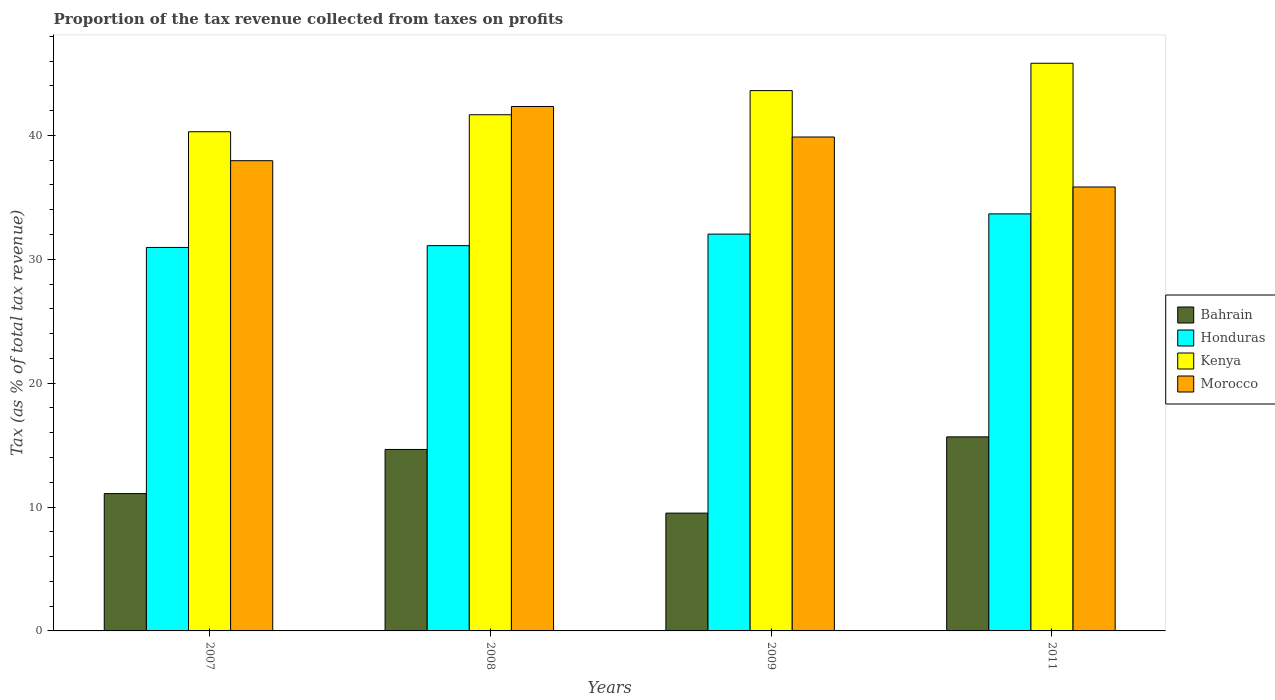How many different coloured bars are there?
Offer a very short reply. 4. How many groups of bars are there?
Ensure brevity in your answer.  4. Are the number of bars per tick equal to the number of legend labels?
Make the answer very short. Yes. Are the number of bars on each tick of the X-axis equal?
Provide a succinct answer. Yes. What is the label of the 3rd group of bars from the left?
Offer a terse response. 2009. In how many cases, is the number of bars for a given year not equal to the number of legend labels?
Make the answer very short. 0. What is the proportion of the tax revenue collected in Honduras in 2011?
Your answer should be compact. 33.66. Across all years, what is the maximum proportion of the tax revenue collected in Kenya?
Ensure brevity in your answer.  45.82. Across all years, what is the minimum proportion of the tax revenue collected in Kenya?
Give a very brief answer. 40.29. In which year was the proportion of the tax revenue collected in Kenya maximum?
Make the answer very short. 2011. In which year was the proportion of the tax revenue collected in Morocco minimum?
Your answer should be very brief. 2011. What is the total proportion of the tax revenue collected in Bahrain in the graph?
Your answer should be very brief. 50.9. What is the difference between the proportion of the tax revenue collected in Morocco in 2007 and that in 2009?
Ensure brevity in your answer.  -1.91. What is the difference between the proportion of the tax revenue collected in Honduras in 2011 and the proportion of the tax revenue collected in Bahrain in 2009?
Your response must be concise. 24.15. What is the average proportion of the tax revenue collected in Morocco per year?
Provide a short and direct response. 39. In the year 2009, what is the difference between the proportion of the tax revenue collected in Morocco and proportion of the tax revenue collected in Kenya?
Ensure brevity in your answer.  -3.75. In how many years, is the proportion of the tax revenue collected in Kenya greater than 26 %?
Your answer should be very brief. 4. What is the ratio of the proportion of the tax revenue collected in Kenya in 2008 to that in 2011?
Your answer should be very brief. 0.91. Is the proportion of the tax revenue collected in Honduras in 2007 less than that in 2009?
Give a very brief answer. Yes. What is the difference between the highest and the second highest proportion of the tax revenue collected in Morocco?
Make the answer very short. 2.46. What is the difference between the highest and the lowest proportion of the tax revenue collected in Honduras?
Make the answer very short. 2.71. Is the sum of the proportion of the tax revenue collected in Morocco in 2007 and 2011 greater than the maximum proportion of the tax revenue collected in Honduras across all years?
Keep it short and to the point. Yes. What does the 4th bar from the left in 2007 represents?
Provide a short and direct response. Morocco. What does the 2nd bar from the right in 2008 represents?
Offer a terse response. Kenya. How many years are there in the graph?
Keep it short and to the point. 4. Are the values on the major ticks of Y-axis written in scientific E-notation?
Your response must be concise. No. Does the graph contain grids?
Offer a terse response. No. Where does the legend appear in the graph?
Give a very brief answer. Center right. How are the legend labels stacked?
Ensure brevity in your answer.  Vertical. What is the title of the graph?
Offer a terse response. Proportion of the tax revenue collected from taxes on profits. Does "Upper middle income" appear as one of the legend labels in the graph?
Give a very brief answer. No. What is the label or title of the Y-axis?
Ensure brevity in your answer.  Tax (as % of total tax revenue). What is the Tax (as % of total tax revenue) of Bahrain in 2007?
Make the answer very short. 11.08. What is the Tax (as % of total tax revenue) of Honduras in 2007?
Your response must be concise. 30.95. What is the Tax (as % of total tax revenue) in Kenya in 2007?
Make the answer very short. 40.29. What is the Tax (as % of total tax revenue) of Morocco in 2007?
Give a very brief answer. 37.96. What is the Tax (as % of total tax revenue) in Bahrain in 2008?
Offer a terse response. 14.65. What is the Tax (as % of total tax revenue) of Honduras in 2008?
Give a very brief answer. 31.1. What is the Tax (as % of total tax revenue) in Kenya in 2008?
Give a very brief answer. 41.67. What is the Tax (as % of total tax revenue) in Morocco in 2008?
Your response must be concise. 42.33. What is the Tax (as % of total tax revenue) in Bahrain in 2009?
Keep it short and to the point. 9.51. What is the Tax (as % of total tax revenue) of Honduras in 2009?
Provide a succinct answer. 32.03. What is the Tax (as % of total tax revenue) of Kenya in 2009?
Offer a terse response. 43.61. What is the Tax (as % of total tax revenue) of Morocco in 2009?
Your response must be concise. 39.87. What is the Tax (as % of total tax revenue) in Bahrain in 2011?
Offer a terse response. 15.66. What is the Tax (as % of total tax revenue) of Honduras in 2011?
Give a very brief answer. 33.66. What is the Tax (as % of total tax revenue) of Kenya in 2011?
Offer a very short reply. 45.82. What is the Tax (as % of total tax revenue) of Morocco in 2011?
Make the answer very short. 35.83. Across all years, what is the maximum Tax (as % of total tax revenue) of Bahrain?
Ensure brevity in your answer.  15.66. Across all years, what is the maximum Tax (as % of total tax revenue) in Honduras?
Provide a short and direct response. 33.66. Across all years, what is the maximum Tax (as % of total tax revenue) in Kenya?
Your answer should be compact. 45.82. Across all years, what is the maximum Tax (as % of total tax revenue) in Morocco?
Offer a terse response. 42.33. Across all years, what is the minimum Tax (as % of total tax revenue) of Bahrain?
Offer a terse response. 9.51. Across all years, what is the minimum Tax (as % of total tax revenue) of Honduras?
Your answer should be compact. 30.95. Across all years, what is the minimum Tax (as % of total tax revenue) of Kenya?
Provide a succinct answer. 40.29. Across all years, what is the minimum Tax (as % of total tax revenue) of Morocco?
Ensure brevity in your answer.  35.83. What is the total Tax (as % of total tax revenue) of Bahrain in the graph?
Offer a terse response. 50.9. What is the total Tax (as % of total tax revenue) in Honduras in the graph?
Keep it short and to the point. 127.74. What is the total Tax (as % of total tax revenue) in Kenya in the graph?
Your answer should be very brief. 171.39. What is the total Tax (as % of total tax revenue) in Morocco in the graph?
Give a very brief answer. 155.99. What is the difference between the Tax (as % of total tax revenue) of Bahrain in 2007 and that in 2008?
Your answer should be compact. -3.56. What is the difference between the Tax (as % of total tax revenue) in Honduras in 2007 and that in 2008?
Offer a terse response. -0.15. What is the difference between the Tax (as % of total tax revenue) of Kenya in 2007 and that in 2008?
Ensure brevity in your answer.  -1.37. What is the difference between the Tax (as % of total tax revenue) in Morocco in 2007 and that in 2008?
Provide a succinct answer. -4.38. What is the difference between the Tax (as % of total tax revenue) in Bahrain in 2007 and that in 2009?
Provide a succinct answer. 1.57. What is the difference between the Tax (as % of total tax revenue) of Honduras in 2007 and that in 2009?
Ensure brevity in your answer.  -1.08. What is the difference between the Tax (as % of total tax revenue) in Kenya in 2007 and that in 2009?
Offer a terse response. -3.32. What is the difference between the Tax (as % of total tax revenue) of Morocco in 2007 and that in 2009?
Your answer should be very brief. -1.91. What is the difference between the Tax (as % of total tax revenue) of Bahrain in 2007 and that in 2011?
Your response must be concise. -4.58. What is the difference between the Tax (as % of total tax revenue) of Honduras in 2007 and that in 2011?
Your response must be concise. -2.71. What is the difference between the Tax (as % of total tax revenue) in Kenya in 2007 and that in 2011?
Provide a succinct answer. -5.53. What is the difference between the Tax (as % of total tax revenue) of Morocco in 2007 and that in 2011?
Your answer should be very brief. 2.12. What is the difference between the Tax (as % of total tax revenue) in Bahrain in 2008 and that in 2009?
Provide a succinct answer. 5.14. What is the difference between the Tax (as % of total tax revenue) in Honduras in 2008 and that in 2009?
Offer a very short reply. -0.93. What is the difference between the Tax (as % of total tax revenue) in Kenya in 2008 and that in 2009?
Keep it short and to the point. -1.95. What is the difference between the Tax (as % of total tax revenue) of Morocco in 2008 and that in 2009?
Your answer should be very brief. 2.46. What is the difference between the Tax (as % of total tax revenue) in Bahrain in 2008 and that in 2011?
Give a very brief answer. -1.01. What is the difference between the Tax (as % of total tax revenue) in Honduras in 2008 and that in 2011?
Offer a very short reply. -2.56. What is the difference between the Tax (as % of total tax revenue) of Kenya in 2008 and that in 2011?
Offer a very short reply. -4.16. What is the difference between the Tax (as % of total tax revenue) of Morocco in 2008 and that in 2011?
Give a very brief answer. 6.5. What is the difference between the Tax (as % of total tax revenue) in Bahrain in 2009 and that in 2011?
Offer a very short reply. -6.15. What is the difference between the Tax (as % of total tax revenue) in Honduras in 2009 and that in 2011?
Your answer should be compact. -1.63. What is the difference between the Tax (as % of total tax revenue) of Kenya in 2009 and that in 2011?
Make the answer very short. -2.21. What is the difference between the Tax (as % of total tax revenue) of Morocco in 2009 and that in 2011?
Keep it short and to the point. 4.04. What is the difference between the Tax (as % of total tax revenue) of Bahrain in 2007 and the Tax (as % of total tax revenue) of Honduras in 2008?
Ensure brevity in your answer.  -20.01. What is the difference between the Tax (as % of total tax revenue) of Bahrain in 2007 and the Tax (as % of total tax revenue) of Kenya in 2008?
Offer a terse response. -30.58. What is the difference between the Tax (as % of total tax revenue) of Bahrain in 2007 and the Tax (as % of total tax revenue) of Morocco in 2008?
Provide a short and direct response. -31.25. What is the difference between the Tax (as % of total tax revenue) of Honduras in 2007 and the Tax (as % of total tax revenue) of Kenya in 2008?
Provide a succinct answer. -10.71. What is the difference between the Tax (as % of total tax revenue) of Honduras in 2007 and the Tax (as % of total tax revenue) of Morocco in 2008?
Give a very brief answer. -11.38. What is the difference between the Tax (as % of total tax revenue) of Kenya in 2007 and the Tax (as % of total tax revenue) of Morocco in 2008?
Your answer should be very brief. -2.04. What is the difference between the Tax (as % of total tax revenue) in Bahrain in 2007 and the Tax (as % of total tax revenue) in Honduras in 2009?
Offer a terse response. -20.95. What is the difference between the Tax (as % of total tax revenue) of Bahrain in 2007 and the Tax (as % of total tax revenue) of Kenya in 2009?
Provide a succinct answer. -32.53. What is the difference between the Tax (as % of total tax revenue) of Bahrain in 2007 and the Tax (as % of total tax revenue) of Morocco in 2009?
Give a very brief answer. -28.78. What is the difference between the Tax (as % of total tax revenue) in Honduras in 2007 and the Tax (as % of total tax revenue) in Kenya in 2009?
Keep it short and to the point. -12.66. What is the difference between the Tax (as % of total tax revenue) of Honduras in 2007 and the Tax (as % of total tax revenue) of Morocco in 2009?
Offer a terse response. -8.92. What is the difference between the Tax (as % of total tax revenue) of Kenya in 2007 and the Tax (as % of total tax revenue) of Morocco in 2009?
Provide a succinct answer. 0.42. What is the difference between the Tax (as % of total tax revenue) in Bahrain in 2007 and the Tax (as % of total tax revenue) in Honduras in 2011?
Your answer should be compact. -22.58. What is the difference between the Tax (as % of total tax revenue) in Bahrain in 2007 and the Tax (as % of total tax revenue) in Kenya in 2011?
Give a very brief answer. -34.74. What is the difference between the Tax (as % of total tax revenue) of Bahrain in 2007 and the Tax (as % of total tax revenue) of Morocco in 2011?
Keep it short and to the point. -24.75. What is the difference between the Tax (as % of total tax revenue) in Honduras in 2007 and the Tax (as % of total tax revenue) in Kenya in 2011?
Your answer should be very brief. -14.87. What is the difference between the Tax (as % of total tax revenue) of Honduras in 2007 and the Tax (as % of total tax revenue) of Morocco in 2011?
Offer a very short reply. -4.88. What is the difference between the Tax (as % of total tax revenue) of Kenya in 2007 and the Tax (as % of total tax revenue) of Morocco in 2011?
Your answer should be compact. 4.46. What is the difference between the Tax (as % of total tax revenue) in Bahrain in 2008 and the Tax (as % of total tax revenue) in Honduras in 2009?
Make the answer very short. -17.38. What is the difference between the Tax (as % of total tax revenue) in Bahrain in 2008 and the Tax (as % of total tax revenue) in Kenya in 2009?
Provide a succinct answer. -28.97. What is the difference between the Tax (as % of total tax revenue) in Bahrain in 2008 and the Tax (as % of total tax revenue) in Morocco in 2009?
Make the answer very short. -25.22. What is the difference between the Tax (as % of total tax revenue) of Honduras in 2008 and the Tax (as % of total tax revenue) of Kenya in 2009?
Offer a very short reply. -12.52. What is the difference between the Tax (as % of total tax revenue) of Honduras in 2008 and the Tax (as % of total tax revenue) of Morocco in 2009?
Provide a succinct answer. -8.77. What is the difference between the Tax (as % of total tax revenue) of Kenya in 2008 and the Tax (as % of total tax revenue) of Morocco in 2009?
Make the answer very short. 1.8. What is the difference between the Tax (as % of total tax revenue) in Bahrain in 2008 and the Tax (as % of total tax revenue) in Honduras in 2011?
Provide a short and direct response. -19.01. What is the difference between the Tax (as % of total tax revenue) of Bahrain in 2008 and the Tax (as % of total tax revenue) of Kenya in 2011?
Your answer should be compact. -31.17. What is the difference between the Tax (as % of total tax revenue) of Bahrain in 2008 and the Tax (as % of total tax revenue) of Morocco in 2011?
Keep it short and to the point. -21.19. What is the difference between the Tax (as % of total tax revenue) of Honduras in 2008 and the Tax (as % of total tax revenue) of Kenya in 2011?
Your response must be concise. -14.72. What is the difference between the Tax (as % of total tax revenue) in Honduras in 2008 and the Tax (as % of total tax revenue) in Morocco in 2011?
Your answer should be very brief. -4.74. What is the difference between the Tax (as % of total tax revenue) of Kenya in 2008 and the Tax (as % of total tax revenue) of Morocco in 2011?
Provide a short and direct response. 5.83. What is the difference between the Tax (as % of total tax revenue) in Bahrain in 2009 and the Tax (as % of total tax revenue) in Honduras in 2011?
Offer a terse response. -24.15. What is the difference between the Tax (as % of total tax revenue) of Bahrain in 2009 and the Tax (as % of total tax revenue) of Kenya in 2011?
Give a very brief answer. -36.31. What is the difference between the Tax (as % of total tax revenue) in Bahrain in 2009 and the Tax (as % of total tax revenue) in Morocco in 2011?
Provide a short and direct response. -26.32. What is the difference between the Tax (as % of total tax revenue) in Honduras in 2009 and the Tax (as % of total tax revenue) in Kenya in 2011?
Your answer should be very brief. -13.79. What is the difference between the Tax (as % of total tax revenue) in Honduras in 2009 and the Tax (as % of total tax revenue) in Morocco in 2011?
Your answer should be very brief. -3.8. What is the difference between the Tax (as % of total tax revenue) of Kenya in 2009 and the Tax (as % of total tax revenue) of Morocco in 2011?
Provide a short and direct response. 7.78. What is the average Tax (as % of total tax revenue) in Bahrain per year?
Keep it short and to the point. 12.73. What is the average Tax (as % of total tax revenue) in Honduras per year?
Ensure brevity in your answer.  31.94. What is the average Tax (as % of total tax revenue) of Kenya per year?
Ensure brevity in your answer.  42.85. What is the average Tax (as % of total tax revenue) in Morocco per year?
Keep it short and to the point. 39. In the year 2007, what is the difference between the Tax (as % of total tax revenue) of Bahrain and Tax (as % of total tax revenue) of Honduras?
Provide a short and direct response. -19.87. In the year 2007, what is the difference between the Tax (as % of total tax revenue) in Bahrain and Tax (as % of total tax revenue) in Kenya?
Keep it short and to the point. -29.21. In the year 2007, what is the difference between the Tax (as % of total tax revenue) of Bahrain and Tax (as % of total tax revenue) of Morocco?
Your answer should be very brief. -26.87. In the year 2007, what is the difference between the Tax (as % of total tax revenue) in Honduras and Tax (as % of total tax revenue) in Kenya?
Provide a short and direct response. -9.34. In the year 2007, what is the difference between the Tax (as % of total tax revenue) of Honduras and Tax (as % of total tax revenue) of Morocco?
Provide a short and direct response. -7. In the year 2007, what is the difference between the Tax (as % of total tax revenue) in Kenya and Tax (as % of total tax revenue) in Morocco?
Provide a succinct answer. 2.34. In the year 2008, what is the difference between the Tax (as % of total tax revenue) in Bahrain and Tax (as % of total tax revenue) in Honduras?
Offer a very short reply. -16.45. In the year 2008, what is the difference between the Tax (as % of total tax revenue) in Bahrain and Tax (as % of total tax revenue) in Kenya?
Offer a very short reply. -27.02. In the year 2008, what is the difference between the Tax (as % of total tax revenue) of Bahrain and Tax (as % of total tax revenue) of Morocco?
Provide a succinct answer. -27.68. In the year 2008, what is the difference between the Tax (as % of total tax revenue) of Honduras and Tax (as % of total tax revenue) of Kenya?
Provide a succinct answer. -10.57. In the year 2008, what is the difference between the Tax (as % of total tax revenue) in Honduras and Tax (as % of total tax revenue) in Morocco?
Your response must be concise. -11.23. In the year 2008, what is the difference between the Tax (as % of total tax revenue) in Kenya and Tax (as % of total tax revenue) in Morocco?
Ensure brevity in your answer.  -0.67. In the year 2009, what is the difference between the Tax (as % of total tax revenue) in Bahrain and Tax (as % of total tax revenue) in Honduras?
Your answer should be compact. -22.52. In the year 2009, what is the difference between the Tax (as % of total tax revenue) of Bahrain and Tax (as % of total tax revenue) of Kenya?
Offer a very short reply. -34.1. In the year 2009, what is the difference between the Tax (as % of total tax revenue) in Bahrain and Tax (as % of total tax revenue) in Morocco?
Offer a very short reply. -30.36. In the year 2009, what is the difference between the Tax (as % of total tax revenue) of Honduras and Tax (as % of total tax revenue) of Kenya?
Offer a terse response. -11.58. In the year 2009, what is the difference between the Tax (as % of total tax revenue) of Honduras and Tax (as % of total tax revenue) of Morocco?
Provide a succinct answer. -7.84. In the year 2009, what is the difference between the Tax (as % of total tax revenue) in Kenya and Tax (as % of total tax revenue) in Morocco?
Make the answer very short. 3.75. In the year 2011, what is the difference between the Tax (as % of total tax revenue) in Bahrain and Tax (as % of total tax revenue) in Honduras?
Give a very brief answer. -18. In the year 2011, what is the difference between the Tax (as % of total tax revenue) of Bahrain and Tax (as % of total tax revenue) of Kenya?
Your answer should be very brief. -30.16. In the year 2011, what is the difference between the Tax (as % of total tax revenue) in Bahrain and Tax (as % of total tax revenue) in Morocco?
Your answer should be very brief. -20.17. In the year 2011, what is the difference between the Tax (as % of total tax revenue) of Honduras and Tax (as % of total tax revenue) of Kenya?
Make the answer very short. -12.16. In the year 2011, what is the difference between the Tax (as % of total tax revenue) of Honduras and Tax (as % of total tax revenue) of Morocco?
Ensure brevity in your answer.  -2.17. In the year 2011, what is the difference between the Tax (as % of total tax revenue) of Kenya and Tax (as % of total tax revenue) of Morocco?
Your response must be concise. 9.99. What is the ratio of the Tax (as % of total tax revenue) in Bahrain in 2007 to that in 2008?
Your answer should be compact. 0.76. What is the ratio of the Tax (as % of total tax revenue) in Honduras in 2007 to that in 2008?
Offer a very short reply. 1. What is the ratio of the Tax (as % of total tax revenue) of Morocco in 2007 to that in 2008?
Keep it short and to the point. 0.9. What is the ratio of the Tax (as % of total tax revenue) in Bahrain in 2007 to that in 2009?
Offer a terse response. 1.17. What is the ratio of the Tax (as % of total tax revenue) of Honduras in 2007 to that in 2009?
Give a very brief answer. 0.97. What is the ratio of the Tax (as % of total tax revenue) in Kenya in 2007 to that in 2009?
Make the answer very short. 0.92. What is the ratio of the Tax (as % of total tax revenue) of Bahrain in 2007 to that in 2011?
Your answer should be compact. 0.71. What is the ratio of the Tax (as % of total tax revenue) of Honduras in 2007 to that in 2011?
Offer a very short reply. 0.92. What is the ratio of the Tax (as % of total tax revenue) in Kenya in 2007 to that in 2011?
Offer a very short reply. 0.88. What is the ratio of the Tax (as % of total tax revenue) of Morocco in 2007 to that in 2011?
Your response must be concise. 1.06. What is the ratio of the Tax (as % of total tax revenue) of Bahrain in 2008 to that in 2009?
Your answer should be compact. 1.54. What is the ratio of the Tax (as % of total tax revenue) of Honduras in 2008 to that in 2009?
Your answer should be compact. 0.97. What is the ratio of the Tax (as % of total tax revenue) in Kenya in 2008 to that in 2009?
Your response must be concise. 0.96. What is the ratio of the Tax (as % of total tax revenue) of Morocco in 2008 to that in 2009?
Provide a short and direct response. 1.06. What is the ratio of the Tax (as % of total tax revenue) in Bahrain in 2008 to that in 2011?
Offer a terse response. 0.94. What is the ratio of the Tax (as % of total tax revenue) in Honduras in 2008 to that in 2011?
Your answer should be compact. 0.92. What is the ratio of the Tax (as % of total tax revenue) in Kenya in 2008 to that in 2011?
Keep it short and to the point. 0.91. What is the ratio of the Tax (as % of total tax revenue) of Morocco in 2008 to that in 2011?
Ensure brevity in your answer.  1.18. What is the ratio of the Tax (as % of total tax revenue) of Bahrain in 2009 to that in 2011?
Offer a very short reply. 0.61. What is the ratio of the Tax (as % of total tax revenue) of Honduras in 2009 to that in 2011?
Keep it short and to the point. 0.95. What is the ratio of the Tax (as % of total tax revenue) in Kenya in 2009 to that in 2011?
Your answer should be very brief. 0.95. What is the ratio of the Tax (as % of total tax revenue) in Morocco in 2009 to that in 2011?
Make the answer very short. 1.11. What is the difference between the highest and the second highest Tax (as % of total tax revenue) of Bahrain?
Provide a short and direct response. 1.01. What is the difference between the highest and the second highest Tax (as % of total tax revenue) of Honduras?
Offer a terse response. 1.63. What is the difference between the highest and the second highest Tax (as % of total tax revenue) of Kenya?
Offer a terse response. 2.21. What is the difference between the highest and the second highest Tax (as % of total tax revenue) in Morocco?
Your answer should be compact. 2.46. What is the difference between the highest and the lowest Tax (as % of total tax revenue) in Bahrain?
Ensure brevity in your answer.  6.15. What is the difference between the highest and the lowest Tax (as % of total tax revenue) of Honduras?
Offer a terse response. 2.71. What is the difference between the highest and the lowest Tax (as % of total tax revenue) of Kenya?
Make the answer very short. 5.53. What is the difference between the highest and the lowest Tax (as % of total tax revenue) in Morocco?
Offer a very short reply. 6.5. 